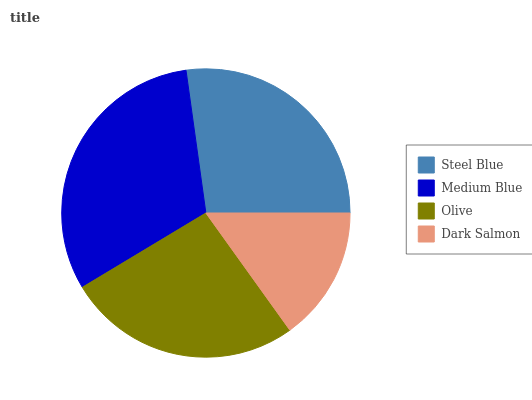Is Dark Salmon the minimum?
Answer yes or no. Yes. Is Medium Blue the maximum?
Answer yes or no. Yes. Is Olive the minimum?
Answer yes or no. No. Is Olive the maximum?
Answer yes or no. No. Is Medium Blue greater than Olive?
Answer yes or no. Yes. Is Olive less than Medium Blue?
Answer yes or no. Yes. Is Olive greater than Medium Blue?
Answer yes or no. No. Is Medium Blue less than Olive?
Answer yes or no. No. Is Steel Blue the high median?
Answer yes or no. Yes. Is Olive the low median?
Answer yes or no. Yes. Is Olive the high median?
Answer yes or no. No. Is Steel Blue the low median?
Answer yes or no. No. 